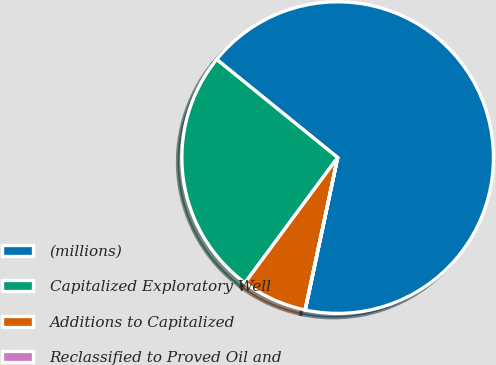Convert chart. <chart><loc_0><loc_0><loc_500><loc_500><pie_chart><fcel>(millions)<fcel>Capitalized Exploratory Well<fcel>Additions to Capitalized<fcel>Reclassified to Proved Oil and<nl><fcel>67.48%<fcel>25.71%<fcel>6.78%<fcel>0.03%<nl></chart> 